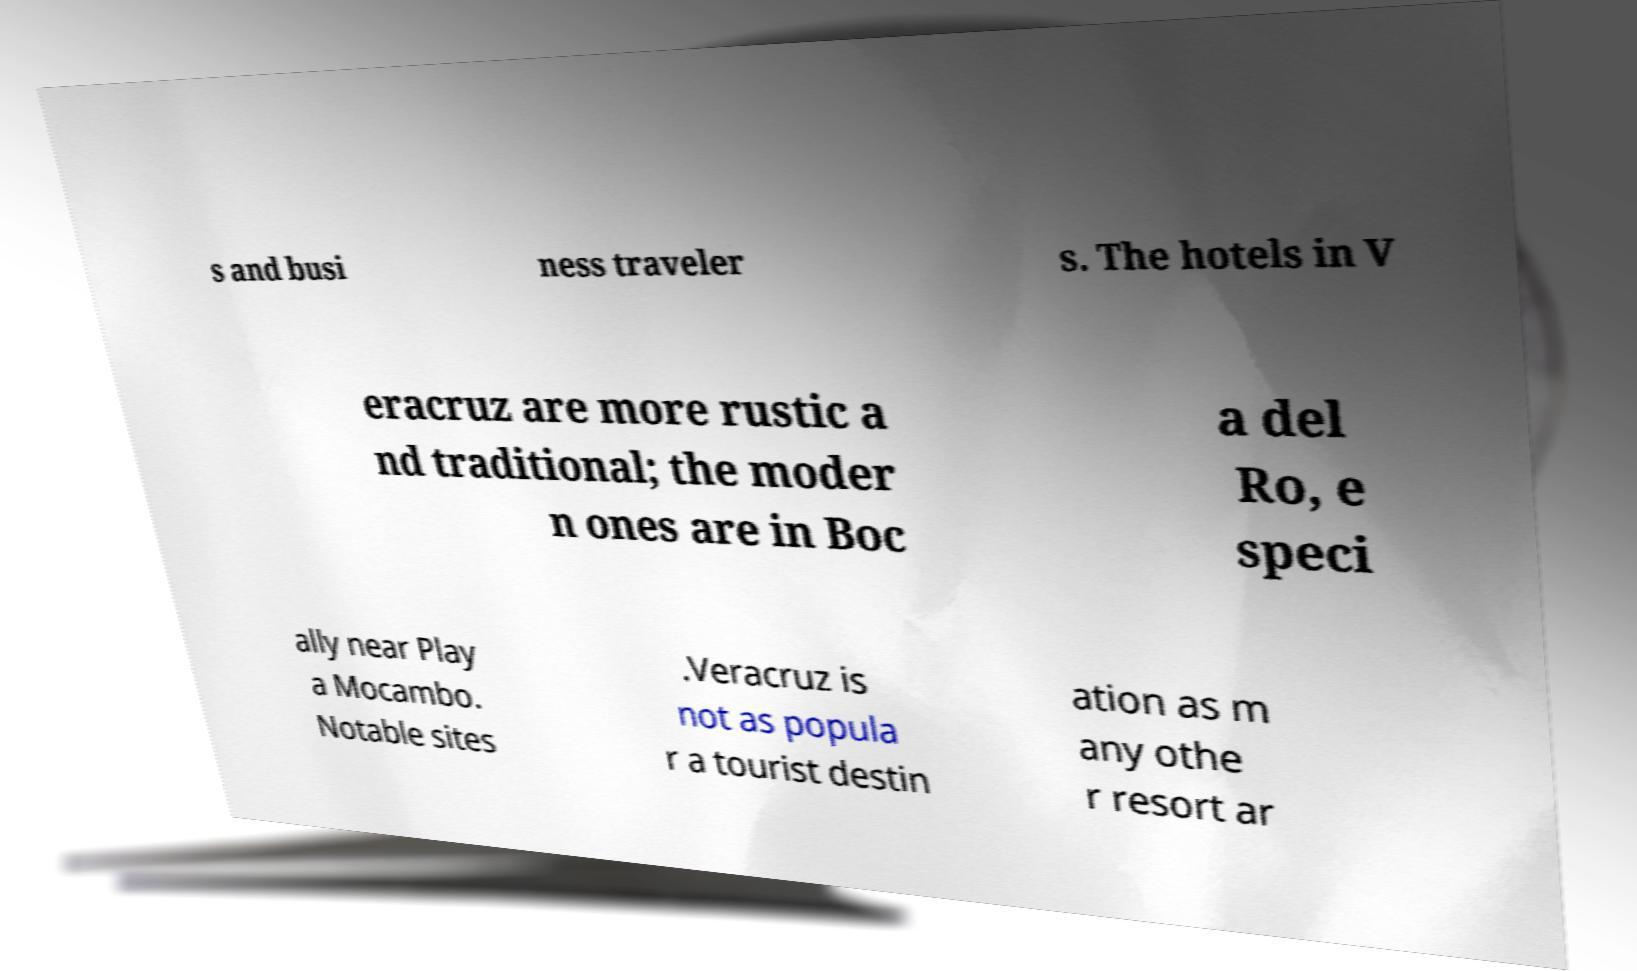For documentation purposes, I need the text within this image transcribed. Could you provide that? s and busi ness traveler s. The hotels in V eracruz are more rustic a nd traditional; the moder n ones are in Boc a del Ro, e speci ally near Play a Mocambo. Notable sites .Veracruz is not as popula r a tourist destin ation as m any othe r resort ar 